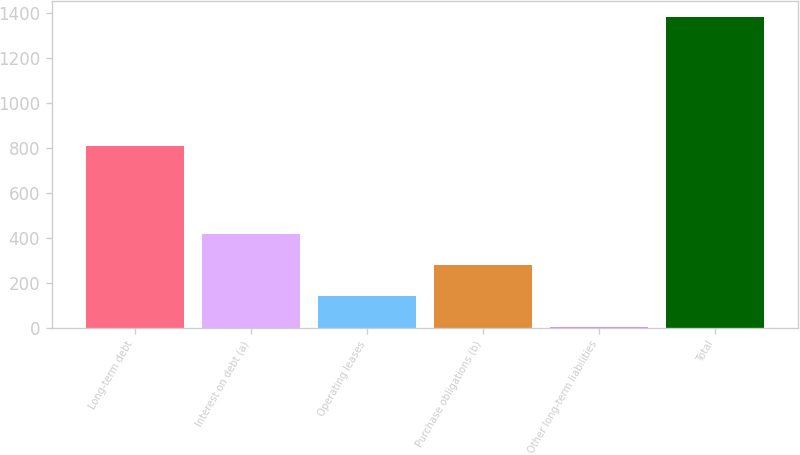Convert chart to OTSL. <chart><loc_0><loc_0><loc_500><loc_500><bar_chart><fcel>Long-term debt<fcel>Interest on debt (a)<fcel>Operating leases<fcel>Purchase obligations (b)<fcel>Other long-term liabilities<fcel>Total<nl><fcel>806<fcel>415.7<fcel>139.9<fcel>277.8<fcel>2<fcel>1381<nl></chart> 